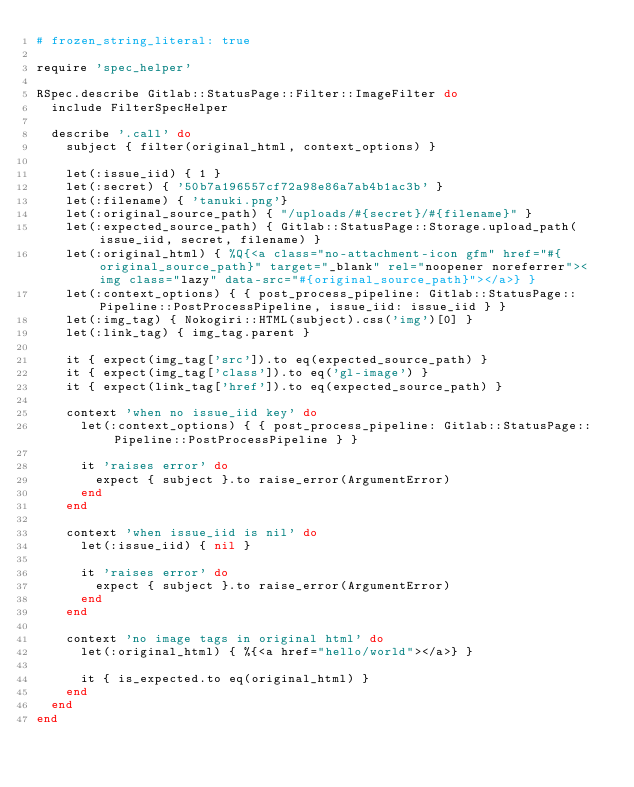<code> <loc_0><loc_0><loc_500><loc_500><_Ruby_># frozen_string_literal: true

require 'spec_helper'

RSpec.describe Gitlab::StatusPage::Filter::ImageFilter do
  include FilterSpecHelper

  describe '.call' do
    subject { filter(original_html, context_options) }

    let(:issue_iid) { 1 }
    let(:secret) { '50b7a196557cf72a98e86a7ab4b1ac3b' }
    let(:filename) { 'tanuki.png'}
    let(:original_source_path) { "/uploads/#{secret}/#{filename}" }
    let(:expected_source_path) { Gitlab::StatusPage::Storage.upload_path(issue_iid, secret, filename) }
    let(:original_html) { %Q{<a class="no-attachment-icon gfm" href="#{original_source_path}" target="_blank" rel="noopener noreferrer"><img class="lazy" data-src="#{original_source_path}"></a>} }
    let(:context_options) { { post_process_pipeline: Gitlab::StatusPage::Pipeline::PostProcessPipeline, issue_iid: issue_iid } }
    let(:img_tag) { Nokogiri::HTML(subject).css('img')[0] }
    let(:link_tag) { img_tag.parent }

    it { expect(img_tag['src']).to eq(expected_source_path) }
    it { expect(img_tag['class']).to eq('gl-image') }
    it { expect(link_tag['href']).to eq(expected_source_path) }

    context 'when no issue_iid key' do
      let(:context_options) { { post_process_pipeline: Gitlab::StatusPage::Pipeline::PostProcessPipeline } }

      it 'raises error' do
        expect { subject }.to raise_error(ArgumentError)
      end
    end

    context 'when issue_iid is nil' do
      let(:issue_iid) { nil }

      it 'raises error' do
        expect { subject }.to raise_error(ArgumentError)
      end
    end

    context 'no image tags in original html' do
      let(:original_html) { %{<a href="hello/world"></a>} }

      it { is_expected.to eq(original_html) }
    end
  end
end
</code> 